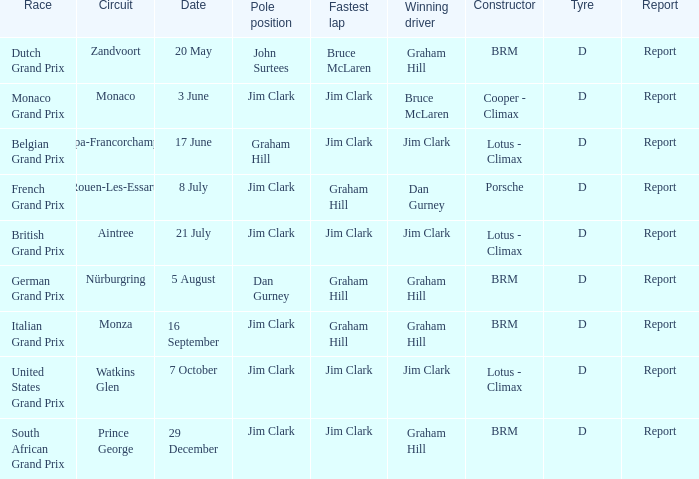What is the tyre on the race where Bruce Mclaren had the fastest lap? D. 